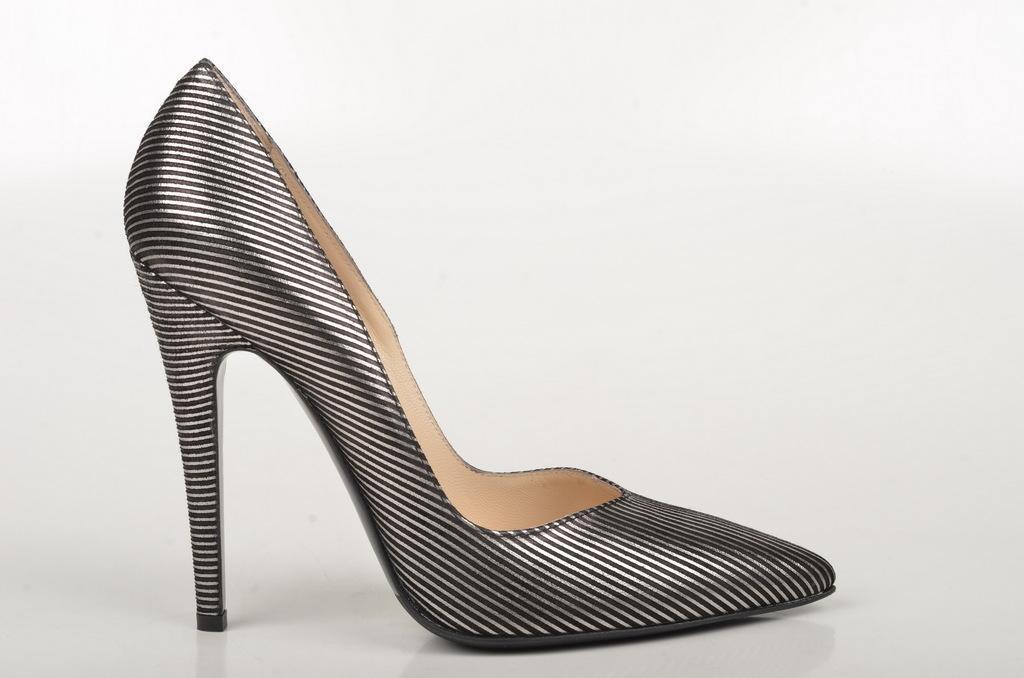Could you give a brief overview of what you see in this image? This image consists of a sandal in black color is kept on the floor. The background is white in color. 